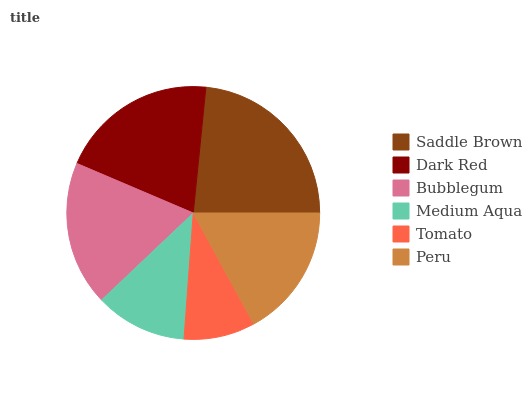Is Tomato the minimum?
Answer yes or no. Yes. Is Saddle Brown the maximum?
Answer yes or no. Yes. Is Dark Red the minimum?
Answer yes or no. No. Is Dark Red the maximum?
Answer yes or no. No. Is Saddle Brown greater than Dark Red?
Answer yes or no. Yes. Is Dark Red less than Saddle Brown?
Answer yes or no. Yes. Is Dark Red greater than Saddle Brown?
Answer yes or no. No. Is Saddle Brown less than Dark Red?
Answer yes or no. No. Is Bubblegum the high median?
Answer yes or no. Yes. Is Peru the low median?
Answer yes or no. Yes. Is Saddle Brown the high median?
Answer yes or no. No. Is Dark Red the low median?
Answer yes or no. No. 